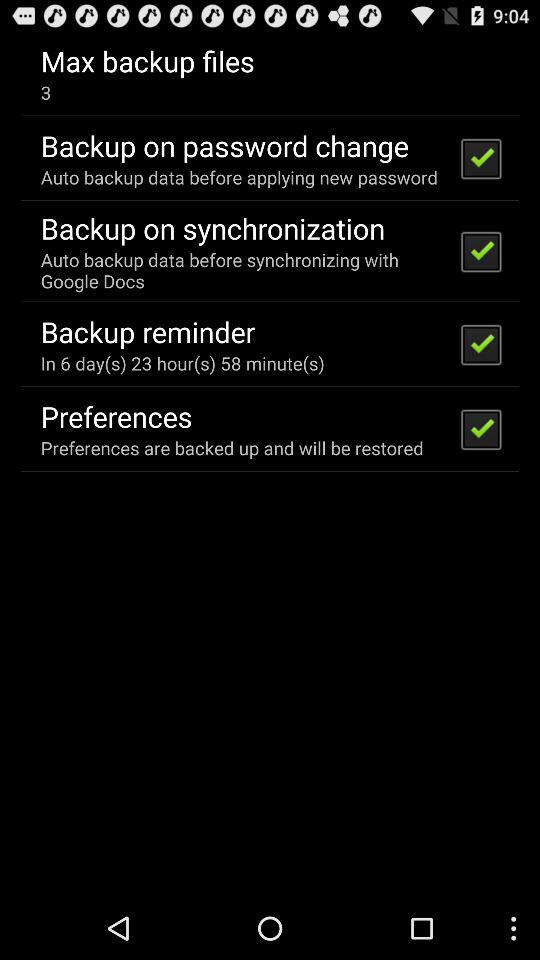How many maximum files can be backed up? There can be a maximum of 3 files to be backed up. 